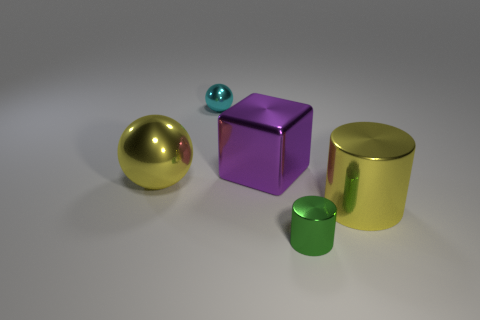Add 1 small spheres. How many objects exist? 6 Subtract all cubes. How many objects are left? 4 Add 2 green shiny cylinders. How many green shiny cylinders are left? 3 Add 1 big purple blocks. How many big purple blocks exist? 2 Subtract 1 purple blocks. How many objects are left? 4 Subtract all brown spheres. Subtract all tiny shiny cylinders. How many objects are left? 4 